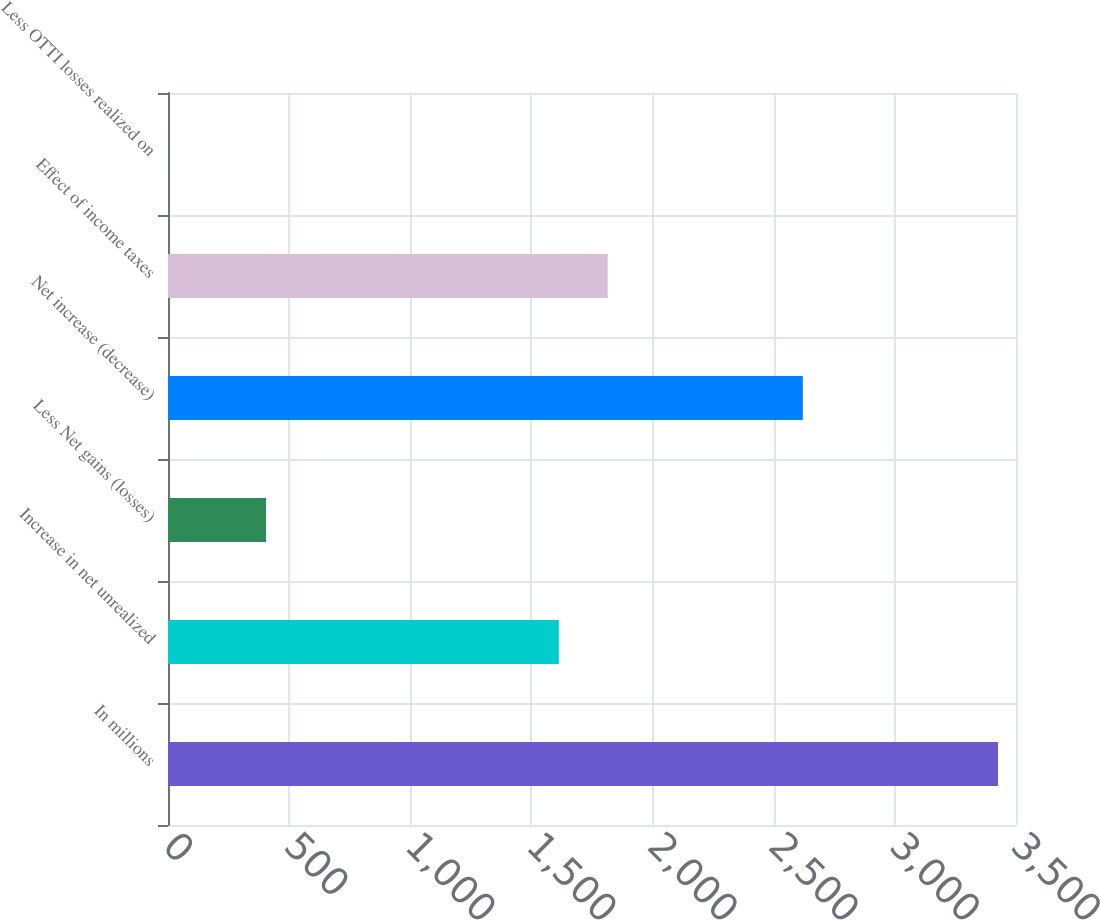Convert chart to OTSL. <chart><loc_0><loc_0><loc_500><loc_500><bar_chart><fcel>In millions<fcel>Increase in net unrealized<fcel>Less Net gains (losses)<fcel>Net increase (decrease)<fcel>Effect of income taxes<fcel>Less OTTI losses realized on<nl><fcel>3425.8<fcel>1613.2<fcel>404.8<fcel>2620.2<fcel>1814.6<fcel>2<nl></chart> 